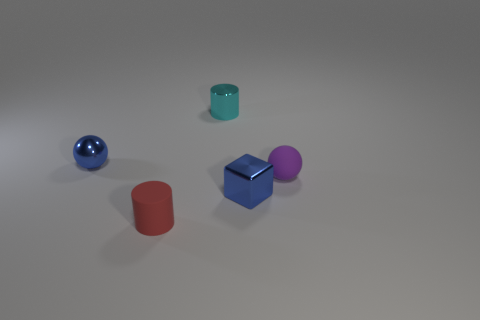Add 5 tiny gray shiny spheres. How many objects exist? 10 Subtract all blue spheres. How many spheres are left? 1 Subtract all balls. How many objects are left? 3 Subtract all tiny green metal cylinders. Subtract all blue things. How many objects are left? 3 Add 3 tiny blue spheres. How many tiny blue spheres are left? 4 Add 1 red things. How many red things exist? 2 Subtract 0 green balls. How many objects are left? 5 Subtract all gray cubes. Subtract all green spheres. How many cubes are left? 1 